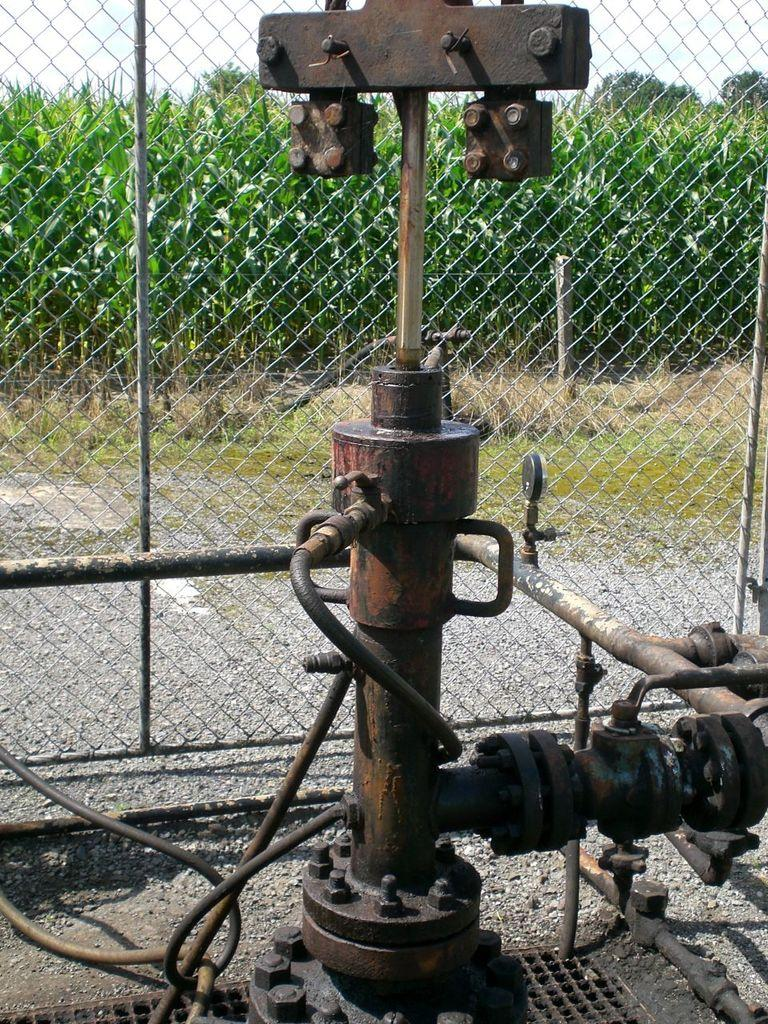What is the main object in the foreground of the image? There is a machine in the foreground of the image. What type of natural environment can be seen in the background? Plants and trees are visible behind a fence in the background of the image. What is visible at the top of the image? The sky is visible at the top of the image. What type of ground is present at the bottom of the image? Grass is present at the bottom of the image. What type of mint can be seen growing near the machine in the image? There is no mint visible in the image; the background features plants and trees, but no specific mention of mint. 